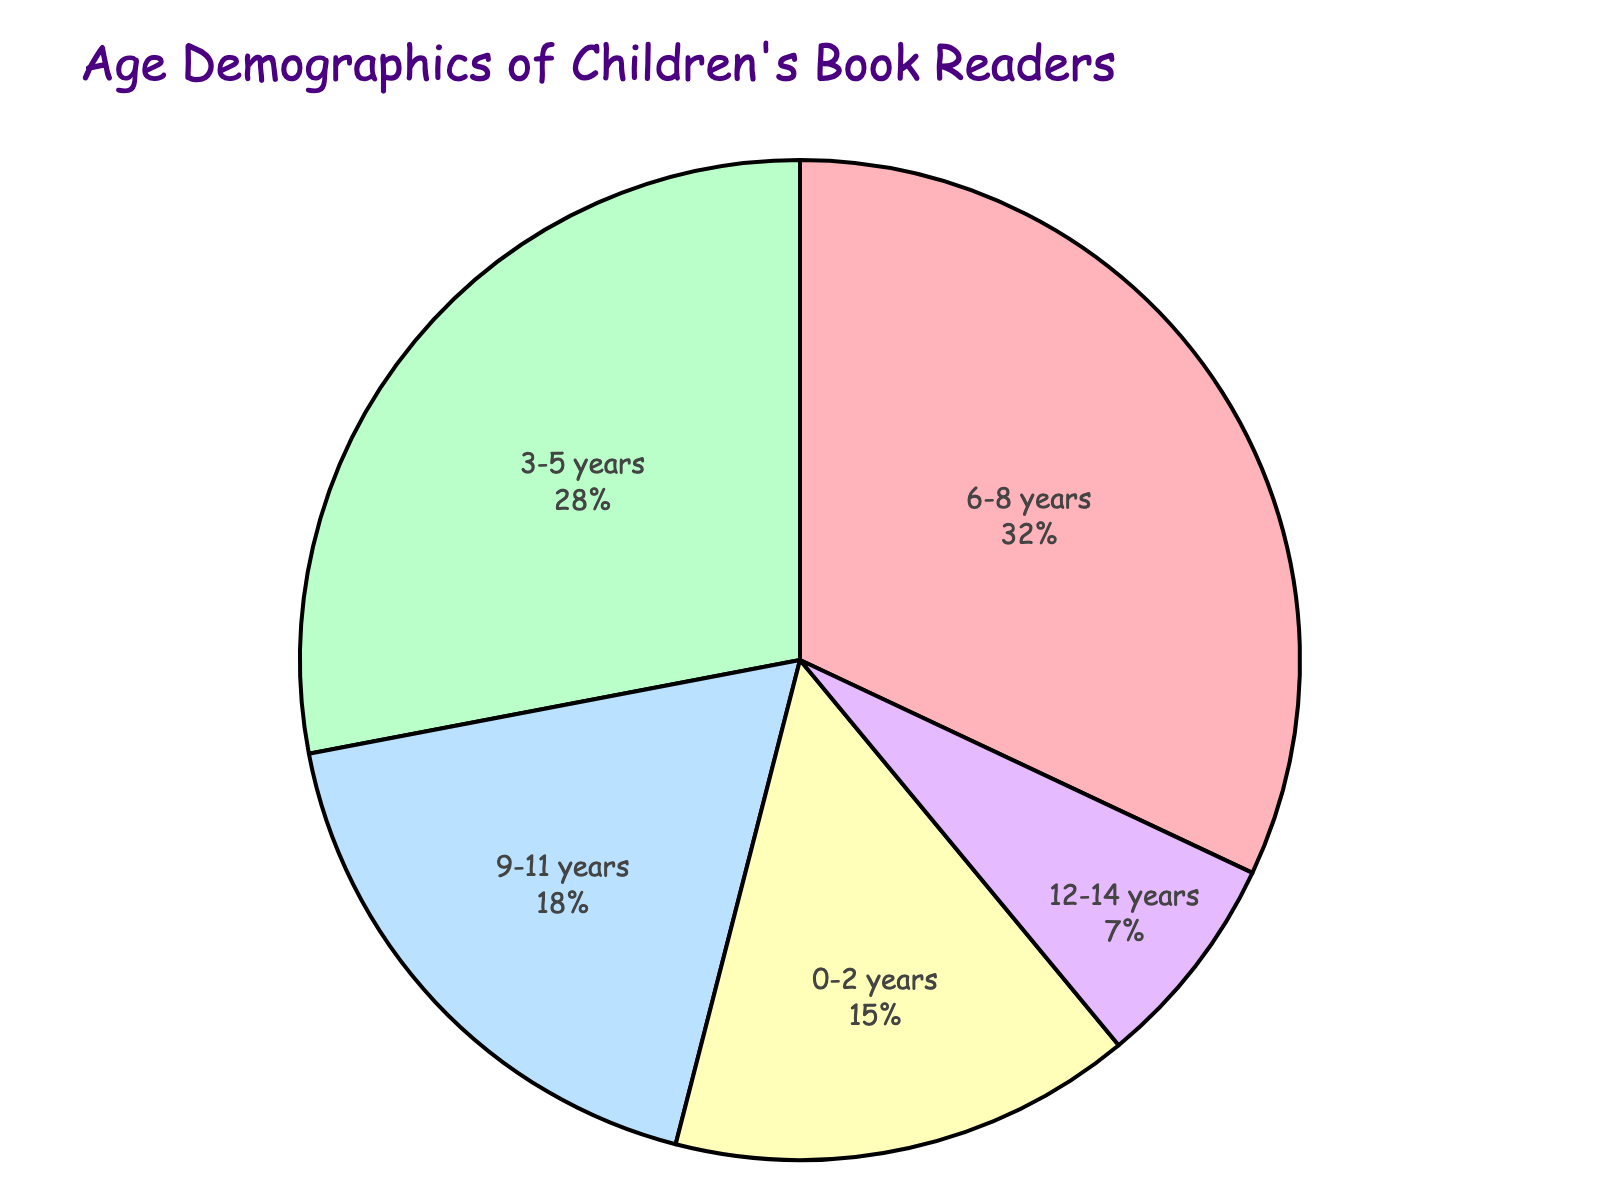What age range represents the smallest percentage of children's book readers? Looking at the pie chart, the smallest segment represents the age range 12-14 years with a percentage of 7%.
Answer: 12-14 years Which age range has the highest percentage of children's book readers, and what is that percentage? By examining the pie chart, the largest segment corresponds to the age range 6-8 years with a percentage of 32%.
Answer: 6-8 years, 32% What is the combined percentage of children's book readers aged 0-2 years and 12-14 years? You need to add the percentages of the age ranges 0-2 years (15%) and 12-14 years (7%). The combined percentage is 15% + 7% = 22%.
Answer: 22% Which age group has a larger percentage of readers: 3-5 years or 9-11 years, and by how much? The age range 3-5 years has a percentage of 28%, and the age range 9-11 years has a percentage of 18%. The difference is 28% - 18% = 10%.
Answer: 3-5 years, by 10% How much more percentage does the age group 6-8 years have compared to the age group 0-2 years? The age range 6-8 years has a percentage of 32%, and the age range 0-2 years has a percentage of 15%. The difference is 32% - 15% = 17%.
Answer: 17% What percentage of the total readers are within the age range of 6 to 11 years? Add the percentages of the age ranges 6-8 years (32%) and 9-11 years (18%). The combined percentage is 32% + 18% = 50%.
Answer: 50% Which age range is represented by a green color in the pie chart? The pie chart uses different colors for each segment, and the green color corresponds to the age range 3-5 years.
Answer: 3-5 years What is the percentage difference between the age groups 3-5 years and 6-8 years? The percentage of the age range 3-5 years is 28%, and for 6-8 years it is 32%. The difference is 32% - 28% = 4%.
Answer: 4% If we group the age ranges 0-8 years and 9-14 years, which group has a higher percentage of readers, and by how much? Sum the percentages for 0-2 years (15%), 3-5 years (28%), and 6-8 years (32%) to get the percentage for 0-8 years: 15% + 28% + 32% = 75%. Sum the percentages for 9-11 years (18%) and 12-14 years (7%) to get the percentage for 9-14 years: 18% + 7% = 25%. The group 0-8 years has a higher percentage by 75% - 25% = 50%.
Answer: 0-8 years, by 50% What's the combined percentage of the two age groups with the smallest percentages of readers? Identify the two smallest percentages, which are 12-14 years (7%) and 9-11 years (18%). Add them together: 7% + 18% = 25%.
Answer: 25% 